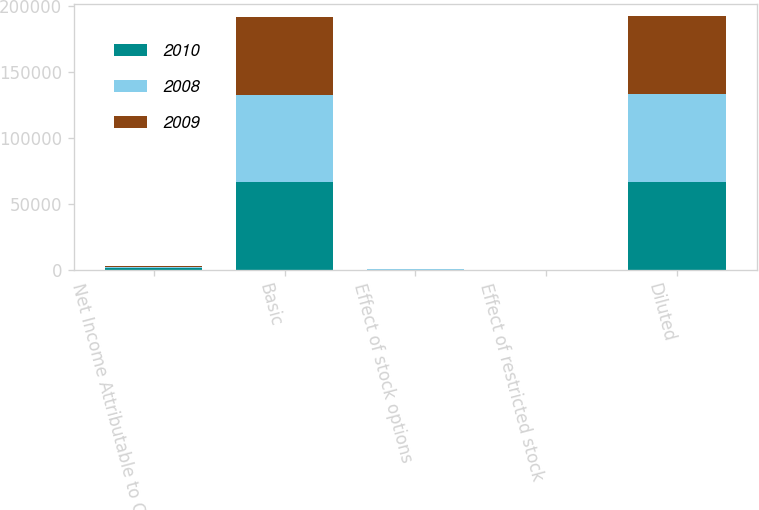<chart> <loc_0><loc_0><loc_500><loc_500><stacked_bar_chart><ecel><fcel>Net Income Attributable to CME<fcel>Basic<fcel>Effect of stock options<fcel>Effect of restricted stock<fcel>Diluted<nl><fcel>2010<fcel>951.4<fcel>66299<fcel>142<fcel>54<fcel>66495<nl><fcel>2008<fcel>825.8<fcel>66366<fcel>158<fcel>24<fcel>66548<nl><fcel>2009<fcel>715.5<fcel>58738<fcel>220<fcel>9<fcel>58967<nl></chart> 